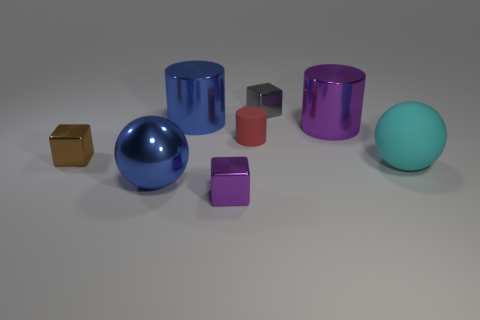There is a cylinder that is the same size as the gray thing; what color is it?
Keep it short and to the point. Red. Are there more tiny red matte cylinders than big shiny things?
Your answer should be compact. No. The metal cylinder that is on the right side of the purple cube is what color?
Your response must be concise. Purple. Is the number of tiny objects in front of the big cyan matte ball greater than the number of large yellow metal cylinders?
Provide a short and direct response. Yes. Does the small brown object have the same material as the tiny gray thing?
Make the answer very short. Yes. What number of other things are the same shape as the gray metal object?
Keep it short and to the point. 2. There is a metal cylinder left of the purple object that is in front of the purple shiny thing behind the brown shiny object; what color is it?
Give a very brief answer. Blue. Do the metallic object that is on the right side of the gray cube and the gray shiny thing have the same shape?
Provide a succinct answer. No. How many large cyan rubber balls are there?
Your answer should be very brief. 1. How many green metallic objects are the same size as the blue metal sphere?
Ensure brevity in your answer.  0. 